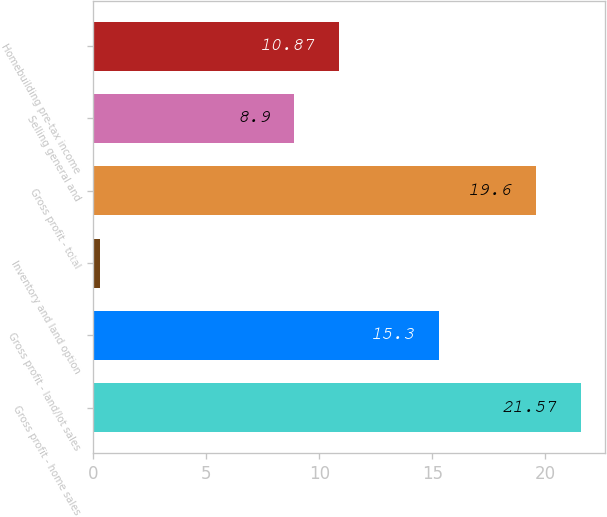<chart> <loc_0><loc_0><loc_500><loc_500><bar_chart><fcel>Gross profit - home sales<fcel>Gross profit - land/lot sales<fcel>Inventory and land option<fcel>Gross profit - total<fcel>Selling general and<fcel>Homebuilding pre-tax income<nl><fcel>21.57<fcel>15.3<fcel>0.3<fcel>19.6<fcel>8.9<fcel>10.87<nl></chart> 